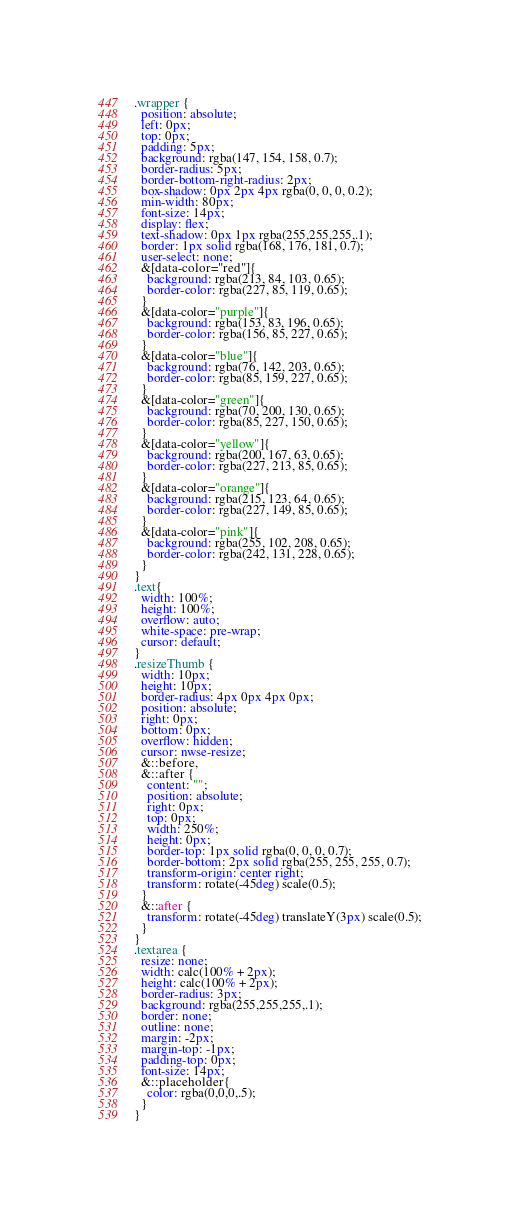Convert code to text. <code><loc_0><loc_0><loc_500><loc_500><_CSS_>.wrapper {
  position: absolute;
  left: 0px;
  top: 0px;
  padding: 5px;
  background: rgba(147, 154, 158, 0.7);
  border-radius: 5px;
  border-bottom-right-radius: 2px;
  box-shadow: 0px 2px 4px rgba(0, 0, 0, 0.2);
  min-width: 80px;
  font-size: 14px;
  display: flex;
  text-shadow: 0px 1px rgba(255,255,255,.1);
  border: 1px solid rgba(168, 176, 181, 0.7);
  user-select: none;
  &[data-color="red"]{
    background: rgba(213, 84, 103, 0.65);
    border-color: rgba(227, 85, 119, 0.65);
  }
  &[data-color="purple"]{
    background: rgba(153, 83, 196, 0.65);
    border-color: rgba(156, 85, 227, 0.65);
  }
  &[data-color="blue"]{
    background: rgba(76, 142, 203, 0.65);
    border-color: rgba(85, 159, 227, 0.65);
  }
  &[data-color="green"]{
    background: rgba(70, 200, 130, 0.65);
    border-color: rgba(85, 227, 150, 0.65);
  }
  &[data-color="yellow"]{
    background: rgba(200, 167, 63, 0.65);
    border-color: rgba(227, 213, 85, 0.65);
  }
  &[data-color="orange"]{
    background: rgba(215, 123, 64, 0.65);
    border-color: rgba(227, 149, 85, 0.65);
  }
  &[data-color="pink"]{
    background: rgba(255, 102, 208, 0.65);
    border-color: rgba(242, 131, 228, 0.65);
  }
}
.text{
  width: 100%;
  height: 100%;
  overflow: auto;
  white-space: pre-wrap;
  cursor: default;
}
.resizeThumb {
  width: 10px;
  height: 10px;
  border-radius: 4px 0px 4px 0px;
  position: absolute;
  right: 0px;
  bottom: 0px;
  overflow: hidden;
  cursor: nwse-resize;
  &::before,
  &::after {
    content: "";
    position: absolute;
    right: 0px;
    top: 0px;
    width: 250%;
    height: 0px;
    border-top: 1px solid rgba(0, 0, 0, 0.7);
    border-bottom: 2px solid rgba(255, 255, 255, 0.7);
    transform-origin: center right;
    transform: rotate(-45deg) scale(0.5);
  }
  &::after {
    transform: rotate(-45deg) translateY(3px) scale(0.5);
  }
}
.textarea {
  resize: none;
  width: calc(100% + 2px);
  height: calc(100% + 2px);
  border-radius: 3px;
  background: rgba(255,255,255,.1);
  border: none;
  outline: none;
  margin: -2px;
  margin-top: -1px;
  padding-top: 0px;
  font-size: 14px;
  &::placeholder{
    color: rgba(0,0,0,.5);
  }
}
</code> 